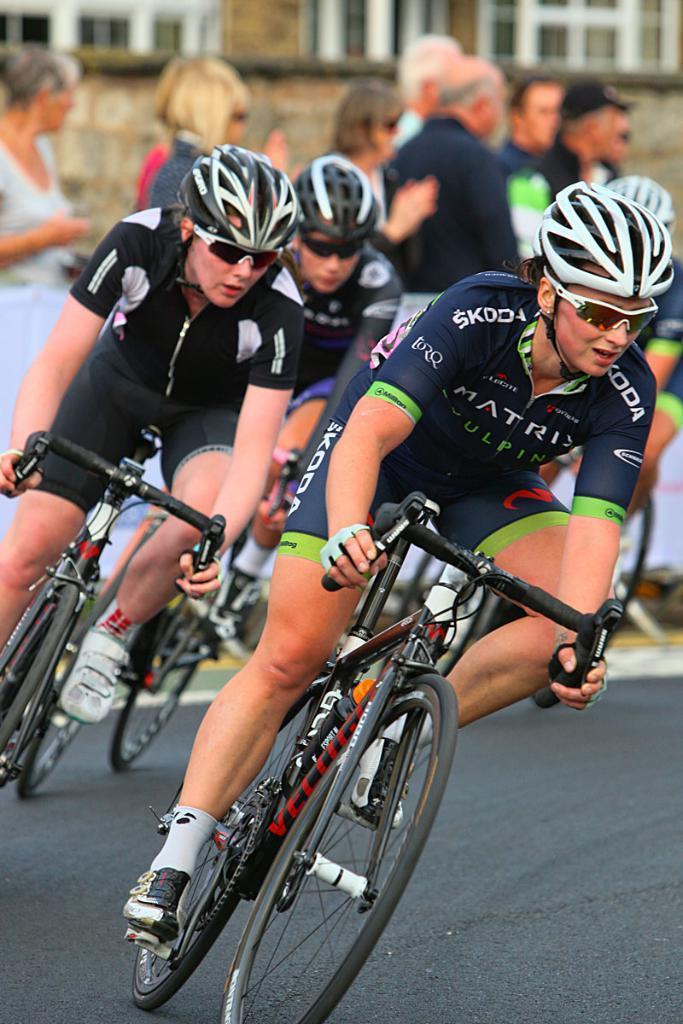Please provide a concise description of this image. Here we can see three persons are riding a bicycle. This is road. They wear a helmet and they have goggles. Here we can see some persons. And there is a building. 